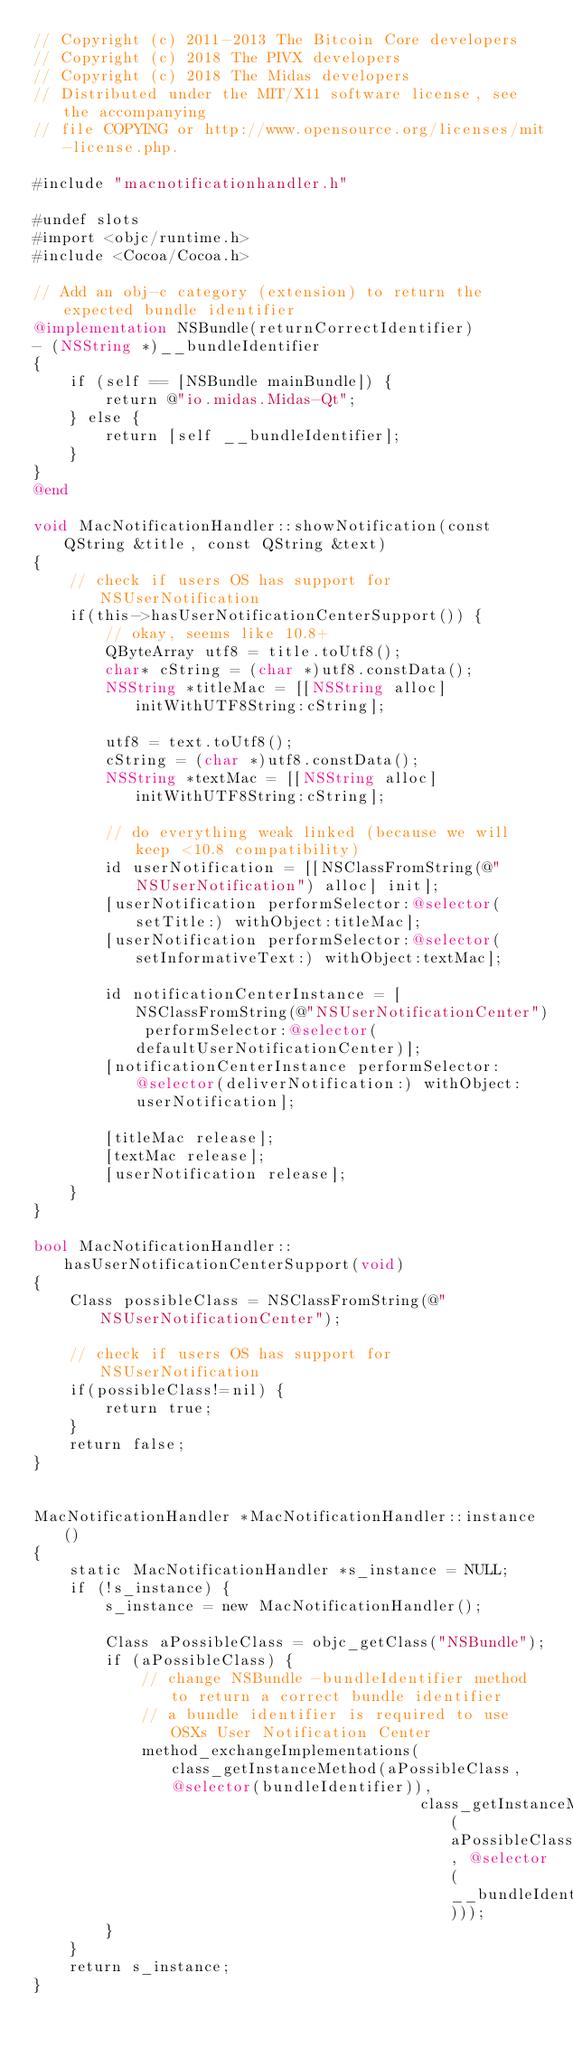Convert code to text. <code><loc_0><loc_0><loc_500><loc_500><_ObjectiveC_>// Copyright (c) 2011-2013 The Bitcoin Core developers
// Copyright (c) 2018 The PIVX developers
// Copyright (c) 2018 The Midas developers
// Distributed under the MIT/X11 software license, see the accompanying
// file COPYING or http://www.opensource.org/licenses/mit-license.php.

#include "macnotificationhandler.h"

#undef slots
#import <objc/runtime.h>
#include <Cocoa/Cocoa.h>

// Add an obj-c category (extension) to return the expected bundle identifier
@implementation NSBundle(returnCorrectIdentifier)
- (NSString *)__bundleIdentifier
{
    if (self == [NSBundle mainBundle]) {
        return @"io.midas.Midas-Qt";
    } else {
        return [self __bundleIdentifier];
    }
}
@end

void MacNotificationHandler::showNotification(const QString &title, const QString &text)
{
    // check if users OS has support for NSUserNotification
    if(this->hasUserNotificationCenterSupport()) {
        // okay, seems like 10.8+
        QByteArray utf8 = title.toUtf8();
        char* cString = (char *)utf8.constData();
        NSString *titleMac = [[NSString alloc] initWithUTF8String:cString];

        utf8 = text.toUtf8();
        cString = (char *)utf8.constData();
        NSString *textMac = [[NSString alloc] initWithUTF8String:cString];

        // do everything weak linked (because we will keep <10.8 compatibility)
        id userNotification = [[NSClassFromString(@"NSUserNotification") alloc] init];
        [userNotification performSelector:@selector(setTitle:) withObject:titleMac];
        [userNotification performSelector:@selector(setInformativeText:) withObject:textMac];

        id notificationCenterInstance = [NSClassFromString(@"NSUserNotificationCenter") performSelector:@selector(defaultUserNotificationCenter)];
        [notificationCenterInstance performSelector:@selector(deliverNotification:) withObject:userNotification];

        [titleMac release];
        [textMac release];
        [userNotification release];
    }
}

bool MacNotificationHandler::hasUserNotificationCenterSupport(void)
{
    Class possibleClass = NSClassFromString(@"NSUserNotificationCenter");

    // check if users OS has support for NSUserNotification
    if(possibleClass!=nil) {
        return true;
    }
    return false;
}


MacNotificationHandler *MacNotificationHandler::instance()
{
    static MacNotificationHandler *s_instance = NULL;
    if (!s_instance) {
        s_instance = new MacNotificationHandler();
        
        Class aPossibleClass = objc_getClass("NSBundle");
        if (aPossibleClass) {
            // change NSBundle -bundleIdentifier method to return a correct bundle identifier
            // a bundle identifier is required to use OSXs User Notification Center
            method_exchangeImplementations(class_getInstanceMethod(aPossibleClass, @selector(bundleIdentifier)),
                                           class_getInstanceMethod(aPossibleClass, @selector(__bundleIdentifier)));
        }
    }
    return s_instance;
}
</code> 